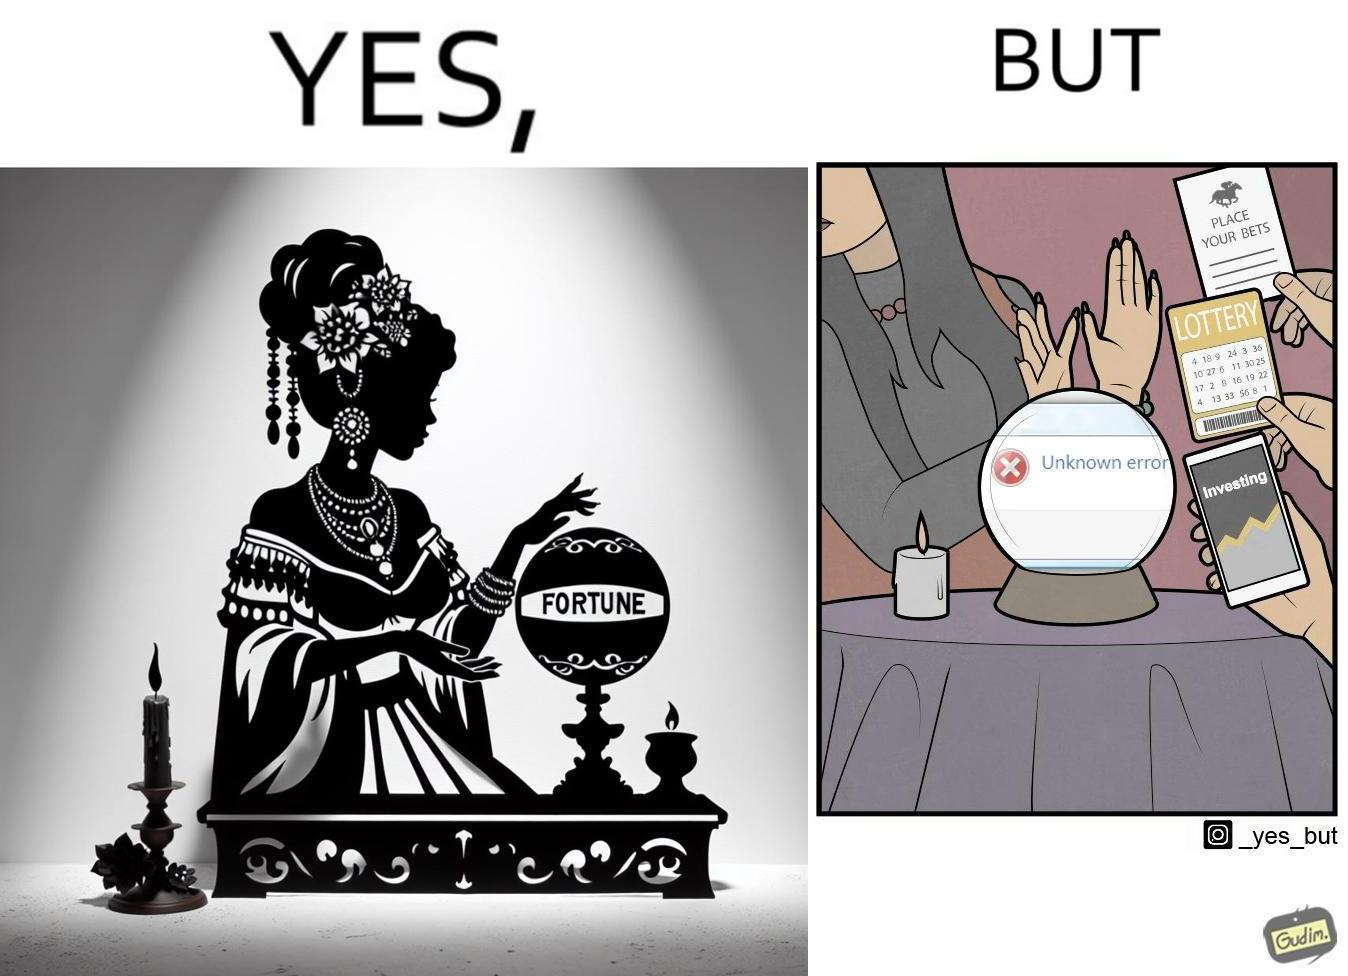What makes this image funny or satirical? The people who claim to predict the future either find their predictions unsuccessful or avoid themselves from making claims related to finance, lotteries, and bets. 